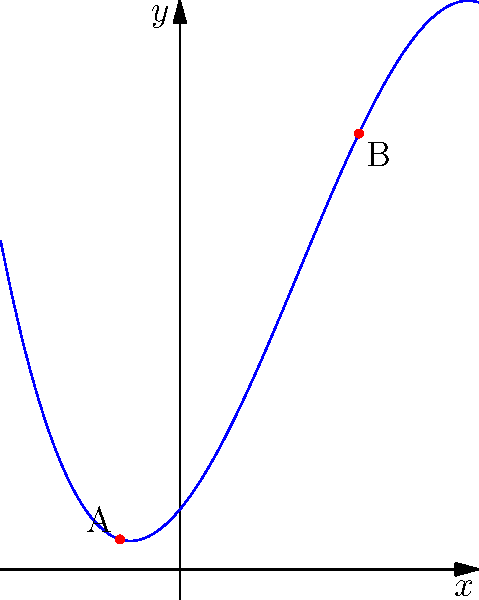As a photojournalist documenting a research project on polynomial functions, you've captured an image of a cubic polynomial graph. The researchers have identified two critical points, labeled A and B. Based on the visual evidence provided, what can you conclude about the behavior of the function near these points? To analyze the behavior of the polynomial function near its turning points, we'll follow these steps:

1. Identify the nature of points A and B:
   - Point A appears to be a local maximum
   - Point B appears to be a local minimum

2. Analyze the behavior around point A:
   - The function increases as x approaches A from the left
   - The function decreases as x moves away from A to the right
   - This indicates a change from positive to negative slope at A

3. Analyze the behavior around point B:
   - The function decreases as x approaches B from the left
   - The function increases as x moves away from B to the right
   - This indicates a change from negative to positive slope at B

4. Interpret the findings:
   - The change in slope direction at both A and B confirms they are turning points
   - Point A is a local maximum because the function changes from increasing to decreasing
   - Point B is a local minimum because the function changes from decreasing to increasing

5. Consider the global behavior:
   - The function appears to decrease without bound as x approaches negative infinity
   - The function appears to increase without bound as x approaches positive infinity
   - This is consistent with the general shape of a cubic function with a negative leading coefficient
Answer: The function exhibits local maximum at A and local minimum at B, changing slope direction at both points. 